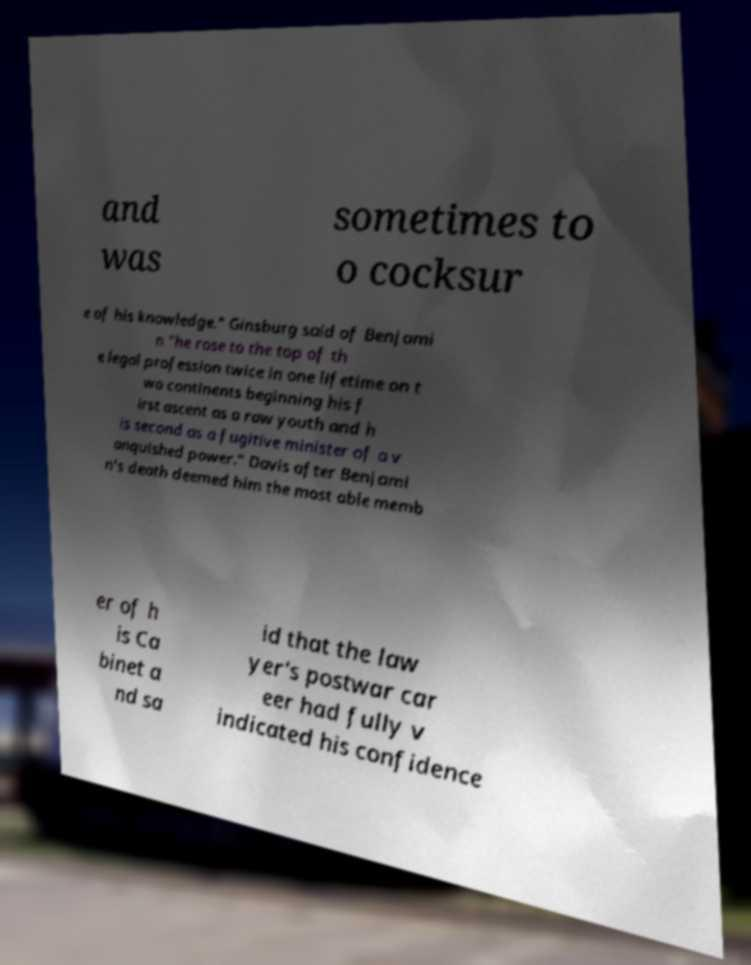Could you extract and type out the text from this image? and was sometimes to o cocksur e of his knowledge." Ginsburg said of Benjami n "he rose to the top of th e legal profession twice in one lifetime on t wo continents beginning his f irst ascent as a raw youth and h is second as a fugitive minister of a v anquished power." Davis after Benjami n's death deemed him the most able memb er of h is Ca binet a nd sa id that the law yer's postwar car eer had fully v indicated his confidence 